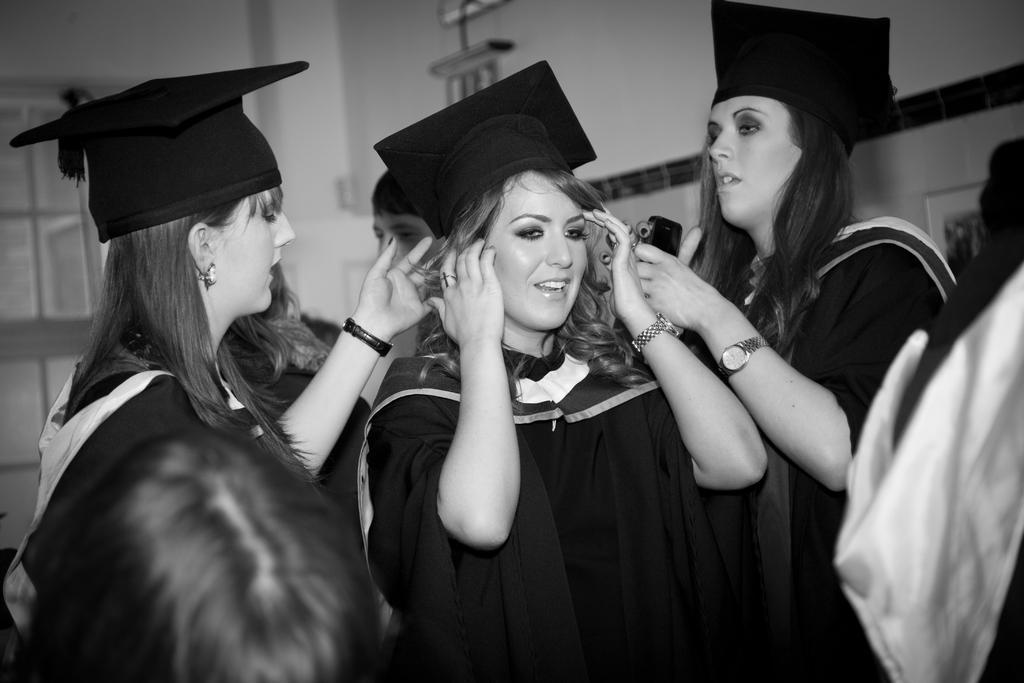Please provide a concise description of this image. It is a black and white image. In this image, we can see a group of people. Here we can see three women are wearing hats. On the right side, a woman is holding a mobile. In the middle of the image, a woman is holding her hair. Background we can see wall, window, photo frame and few objects. 